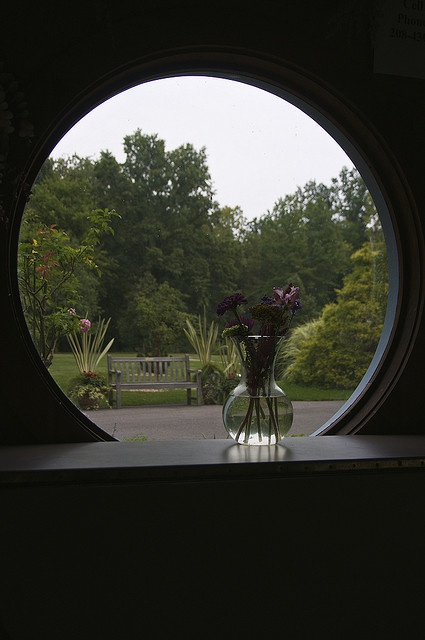Describe the objects in this image and their specific colors. I can see vase in black, darkgreen, gray, and lightgray tones, potted plant in black, darkgreen, gray, and olive tones, bench in black, gray, and darkgreen tones, potted plant in black, darkgreen, and gray tones, and vase in black and gray tones in this image. 